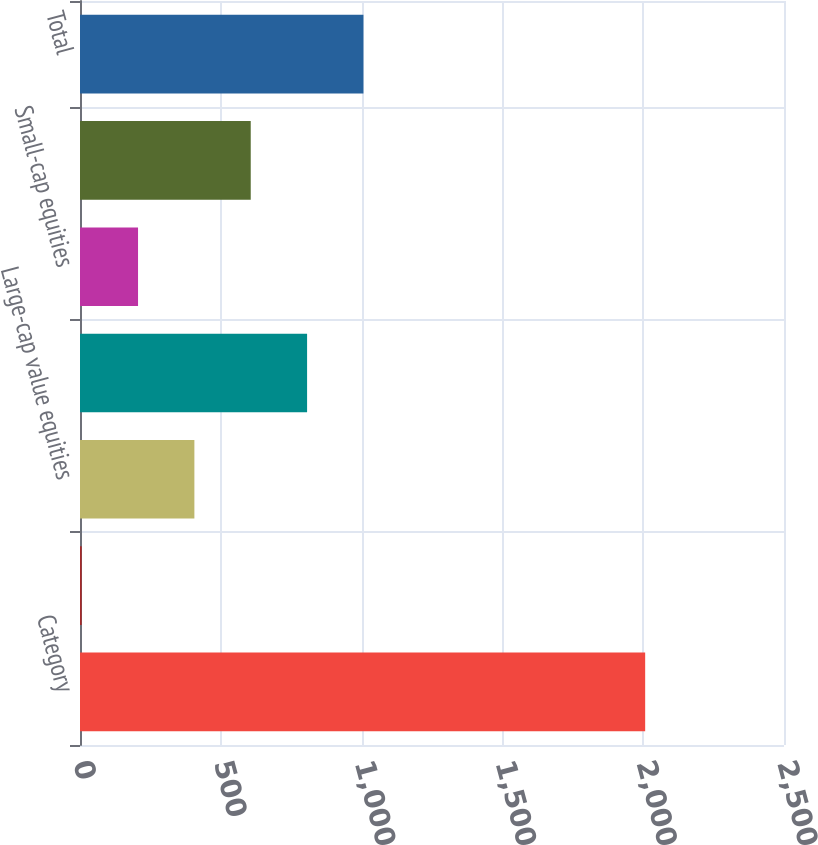<chart> <loc_0><loc_0><loc_500><loc_500><bar_chart><fcel>Category<fcel>Corporate bonds<fcel>Large-cap value equities<fcel>Large-cap growth equities<fcel>Small-cap equities<fcel>International equities<fcel>Total<nl><fcel>2007<fcel>6<fcel>406.2<fcel>806.4<fcel>206.1<fcel>606.3<fcel>1006.5<nl></chart> 